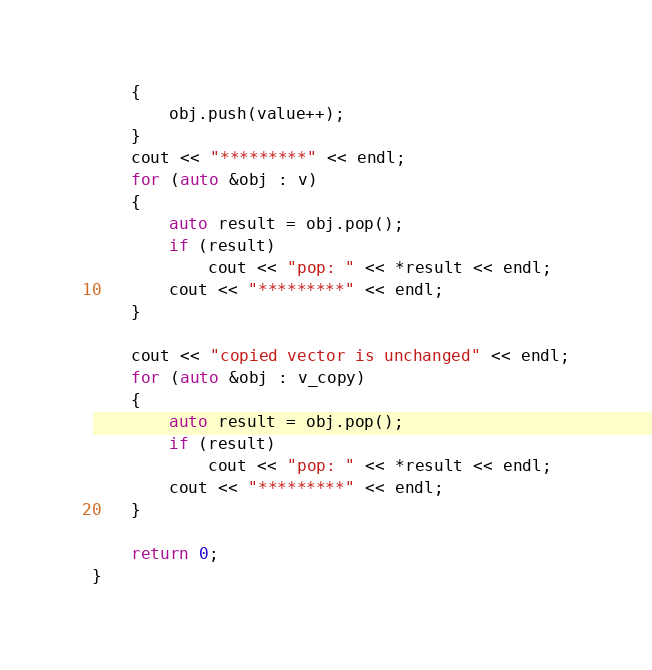<code> <loc_0><loc_0><loc_500><loc_500><_C++_>    {
        obj.push(value++);
    }
    cout << "*********" << endl;
    for (auto &obj : v)
    {
        auto result = obj.pop();
        if (result)
            cout << "pop: " << *result << endl;
        cout << "*********" << endl;
    }

    cout << "copied vector is unchanged" << endl;
    for (auto &obj : v_copy)
    {
        auto result = obj.pop();
        if (result)
            cout << "pop: " << *result << endl;
        cout << "*********" << endl;
    }

    return 0;
}
</code> 